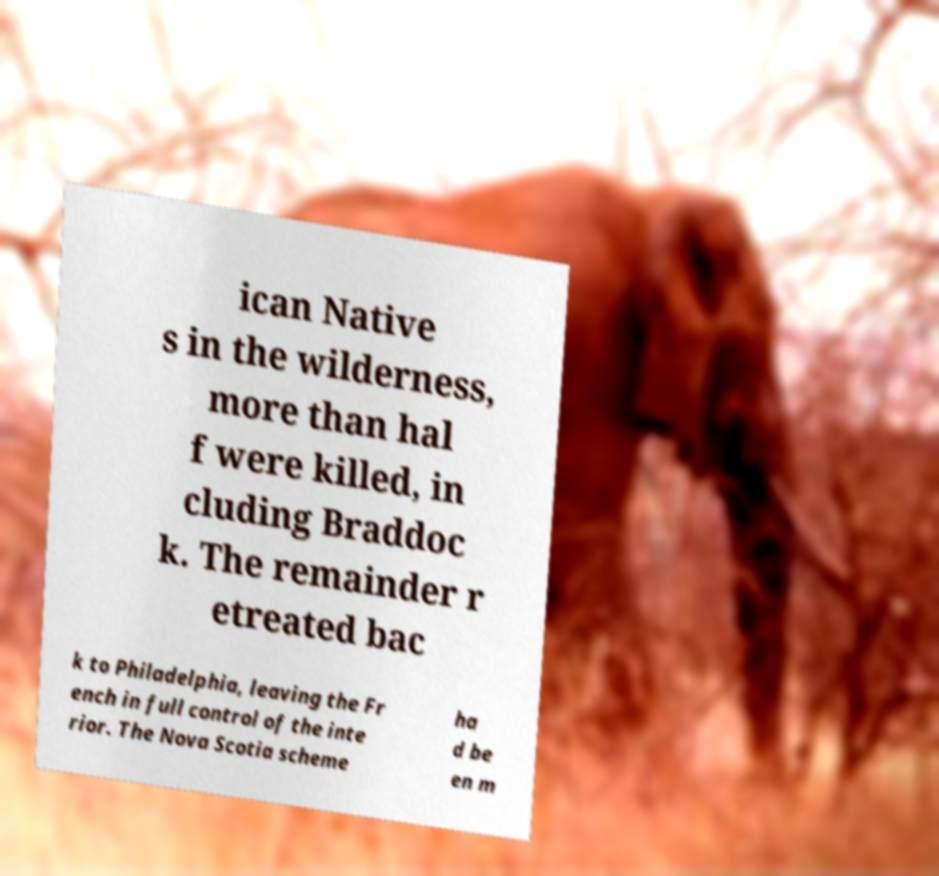I need the written content from this picture converted into text. Can you do that? ican Native s in the wilderness, more than hal f were killed, in cluding Braddoc k. The remainder r etreated bac k to Philadelphia, leaving the Fr ench in full control of the inte rior. The Nova Scotia scheme ha d be en m 